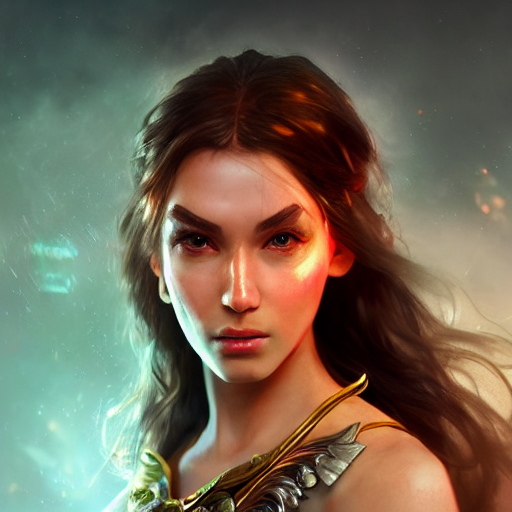Does the image have good lighting?
 Yes 